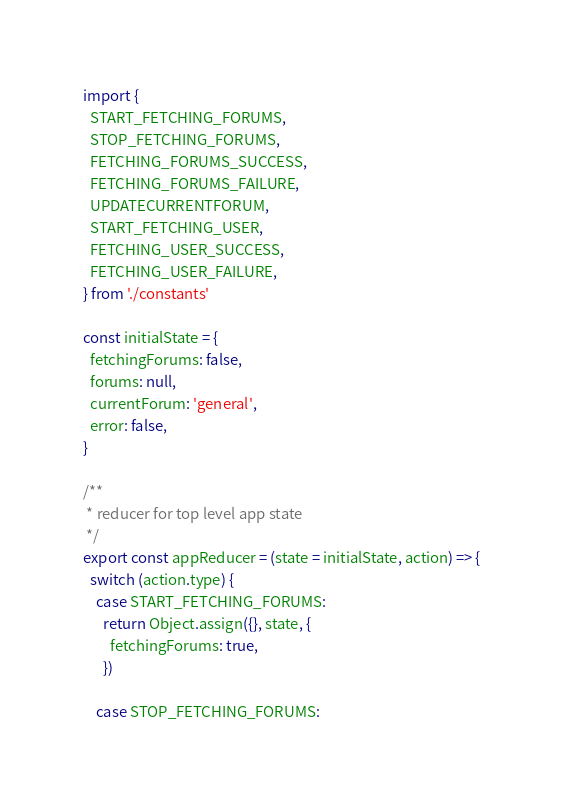<code> <loc_0><loc_0><loc_500><loc_500><_JavaScript_>import {
  START_FETCHING_FORUMS,
  STOP_FETCHING_FORUMS,
  FETCHING_FORUMS_SUCCESS,
  FETCHING_FORUMS_FAILURE,
  UPDATECURRENTFORUM,
  START_FETCHING_USER,
  FETCHING_USER_SUCCESS,
  FETCHING_USER_FAILURE,
} from './constants'

const initialState = {
  fetchingForums: false,
  forums: null,
  currentForum: 'general',
  error: false,
}

/**
 * reducer for top level app state
 */
export const appReducer = (state = initialState, action) => {
  switch (action.type) {
    case START_FETCHING_FORUMS:
      return Object.assign({}, state, {
        fetchingForums: true,
      })

    case STOP_FETCHING_FORUMS:</code> 